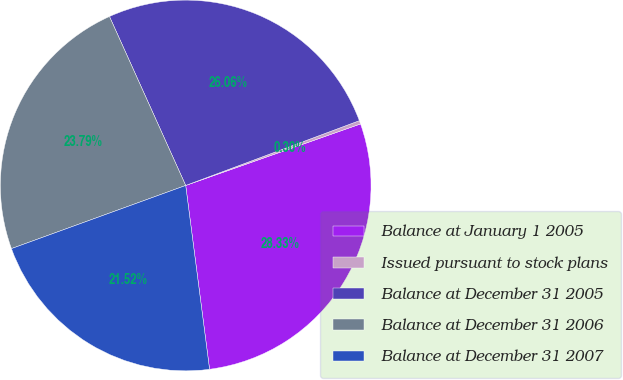Convert chart. <chart><loc_0><loc_0><loc_500><loc_500><pie_chart><fcel>Balance at January 1 2005<fcel>Issued pursuant to stock plans<fcel>Balance at December 31 2005<fcel>Balance at December 31 2006<fcel>Balance at December 31 2007<nl><fcel>28.33%<fcel>0.3%<fcel>26.06%<fcel>23.79%<fcel>21.52%<nl></chart> 